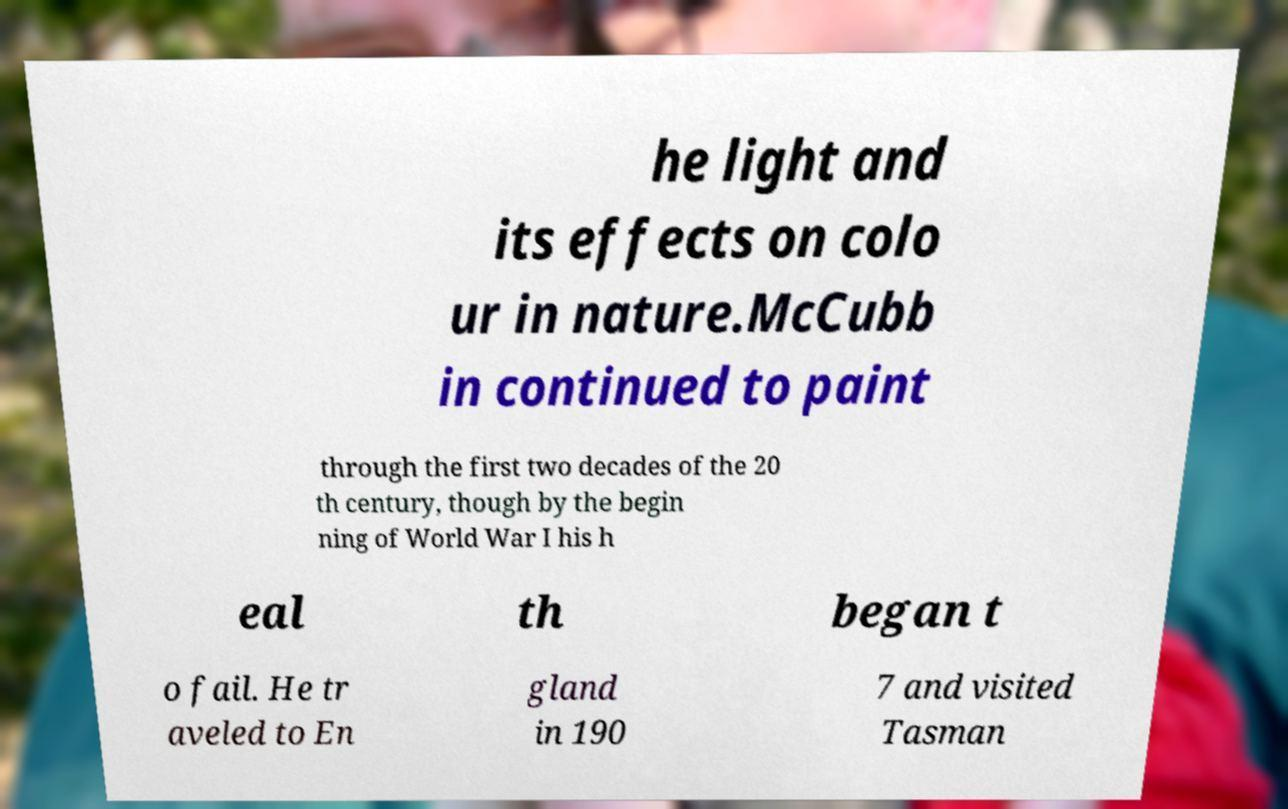Can you read and provide the text displayed in the image?This photo seems to have some interesting text. Can you extract and type it out for me? he light and its effects on colo ur in nature.McCubb in continued to paint through the first two decades of the 20 th century, though by the begin ning of World War I his h eal th began t o fail. He tr aveled to En gland in 190 7 and visited Tasman 